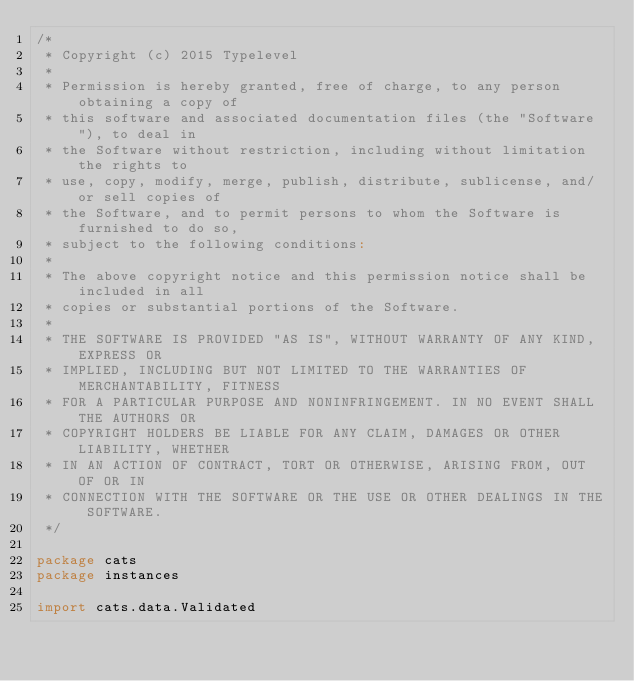<code> <loc_0><loc_0><loc_500><loc_500><_Scala_>/*
 * Copyright (c) 2015 Typelevel
 *
 * Permission is hereby granted, free of charge, to any person obtaining a copy of
 * this software and associated documentation files (the "Software"), to deal in
 * the Software without restriction, including without limitation the rights to
 * use, copy, modify, merge, publish, distribute, sublicense, and/or sell copies of
 * the Software, and to permit persons to whom the Software is furnished to do so,
 * subject to the following conditions:
 *
 * The above copyright notice and this permission notice shall be included in all
 * copies or substantial portions of the Software.
 *
 * THE SOFTWARE IS PROVIDED "AS IS", WITHOUT WARRANTY OF ANY KIND, EXPRESS OR
 * IMPLIED, INCLUDING BUT NOT LIMITED TO THE WARRANTIES OF MERCHANTABILITY, FITNESS
 * FOR A PARTICULAR PURPOSE AND NONINFRINGEMENT. IN NO EVENT SHALL THE AUTHORS OR
 * COPYRIGHT HOLDERS BE LIABLE FOR ANY CLAIM, DAMAGES OR OTHER LIABILITY, WHETHER
 * IN AN ACTION OF CONTRACT, TORT OR OTHERWISE, ARISING FROM, OUT OF OR IN
 * CONNECTION WITH THE SOFTWARE OR THE USE OR OTHER DEALINGS IN THE SOFTWARE.
 */

package cats
package instances

import cats.data.Validated</code> 